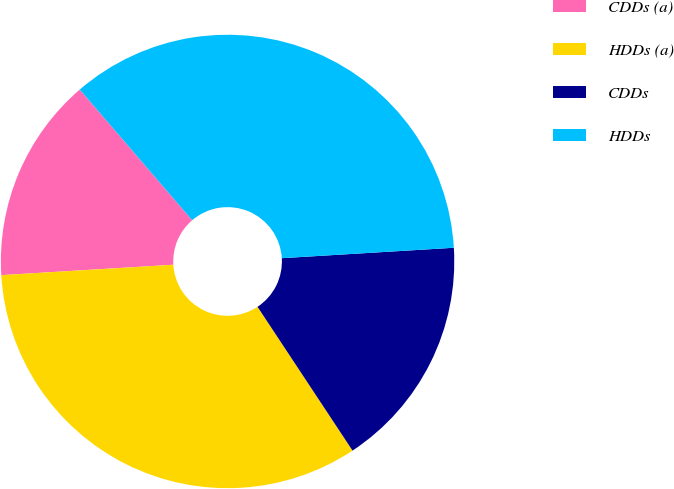<chart> <loc_0><loc_0><loc_500><loc_500><pie_chart><fcel>CDDs (a)<fcel>HDDs (a)<fcel>CDDs<fcel>HDDs<nl><fcel>14.66%<fcel>33.33%<fcel>16.67%<fcel>35.34%<nl></chart> 